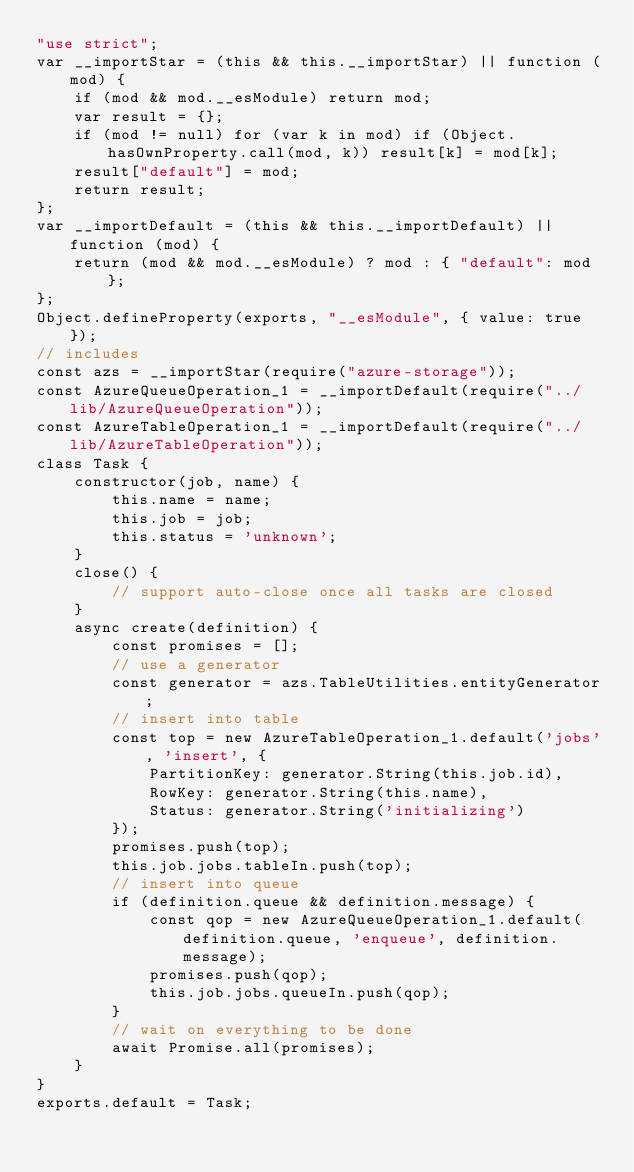<code> <loc_0><loc_0><loc_500><loc_500><_JavaScript_>"use strict";
var __importStar = (this && this.__importStar) || function (mod) {
    if (mod && mod.__esModule) return mod;
    var result = {};
    if (mod != null) for (var k in mod) if (Object.hasOwnProperty.call(mod, k)) result[k] = mod[k];
    result["default"] = mod;
    return result;
};
var __importDefault = (this && this.__importDefault) || function (mod) {
    return (mod && mod.__esModule) ? mod : { "default": mod };
};
Object.defineProperty(exports, "__esModule", { value: true });
// includes
const azs = __importStar(require("azure-storage"));
const AzureQueueOperation_1 = __importDefault(require("../lib/AzureQueueOperation"));
const AzureTableOperation_1 = __importDefault(require("../lib/AzureTableOperation"));
class Task {
    constructor(job, name) {
        this.name = name;
        this.job = job;
        this.status = 'unknown';
    }
    close() {
        // support auto-close once all tasks are closed
    }
    async create(definition) {
        const promises = [];
        // use a generator
        const generator = azs.TableUtilities.entityGenerator;
        // insert into table
        const top = new AzureTableOperation_1.default('jobs', 'insert', {
            PartitionKey: generator.String(this.job.id),
            RowKey: generator.String(this.name),
            Status: generator.String('initializing')
        });
        promises.push(top);
        this.job.jobs.tableIn.push(top);
        // insert into queue
        if (definition.queue && definition.message) {
            const qop = new AzureQueueOperation_1.default(definition.queue, 'enqueue', definition.message);
            promises.push(qop);
            this.job.jobs.queueIn.push(qop);
        }
        // wait on everything to be done
        await Promise.all(promises);
    }
}
exports.default = Task;
</code> 